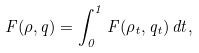<formula> <loc_0><loc_0><loc_500><loc_500>\ F ( \rho , q ) = \int _ { 0 } ^ { 1 } F ( \rho _ { t } , q _ { t } ) \, d t ,</formula> 